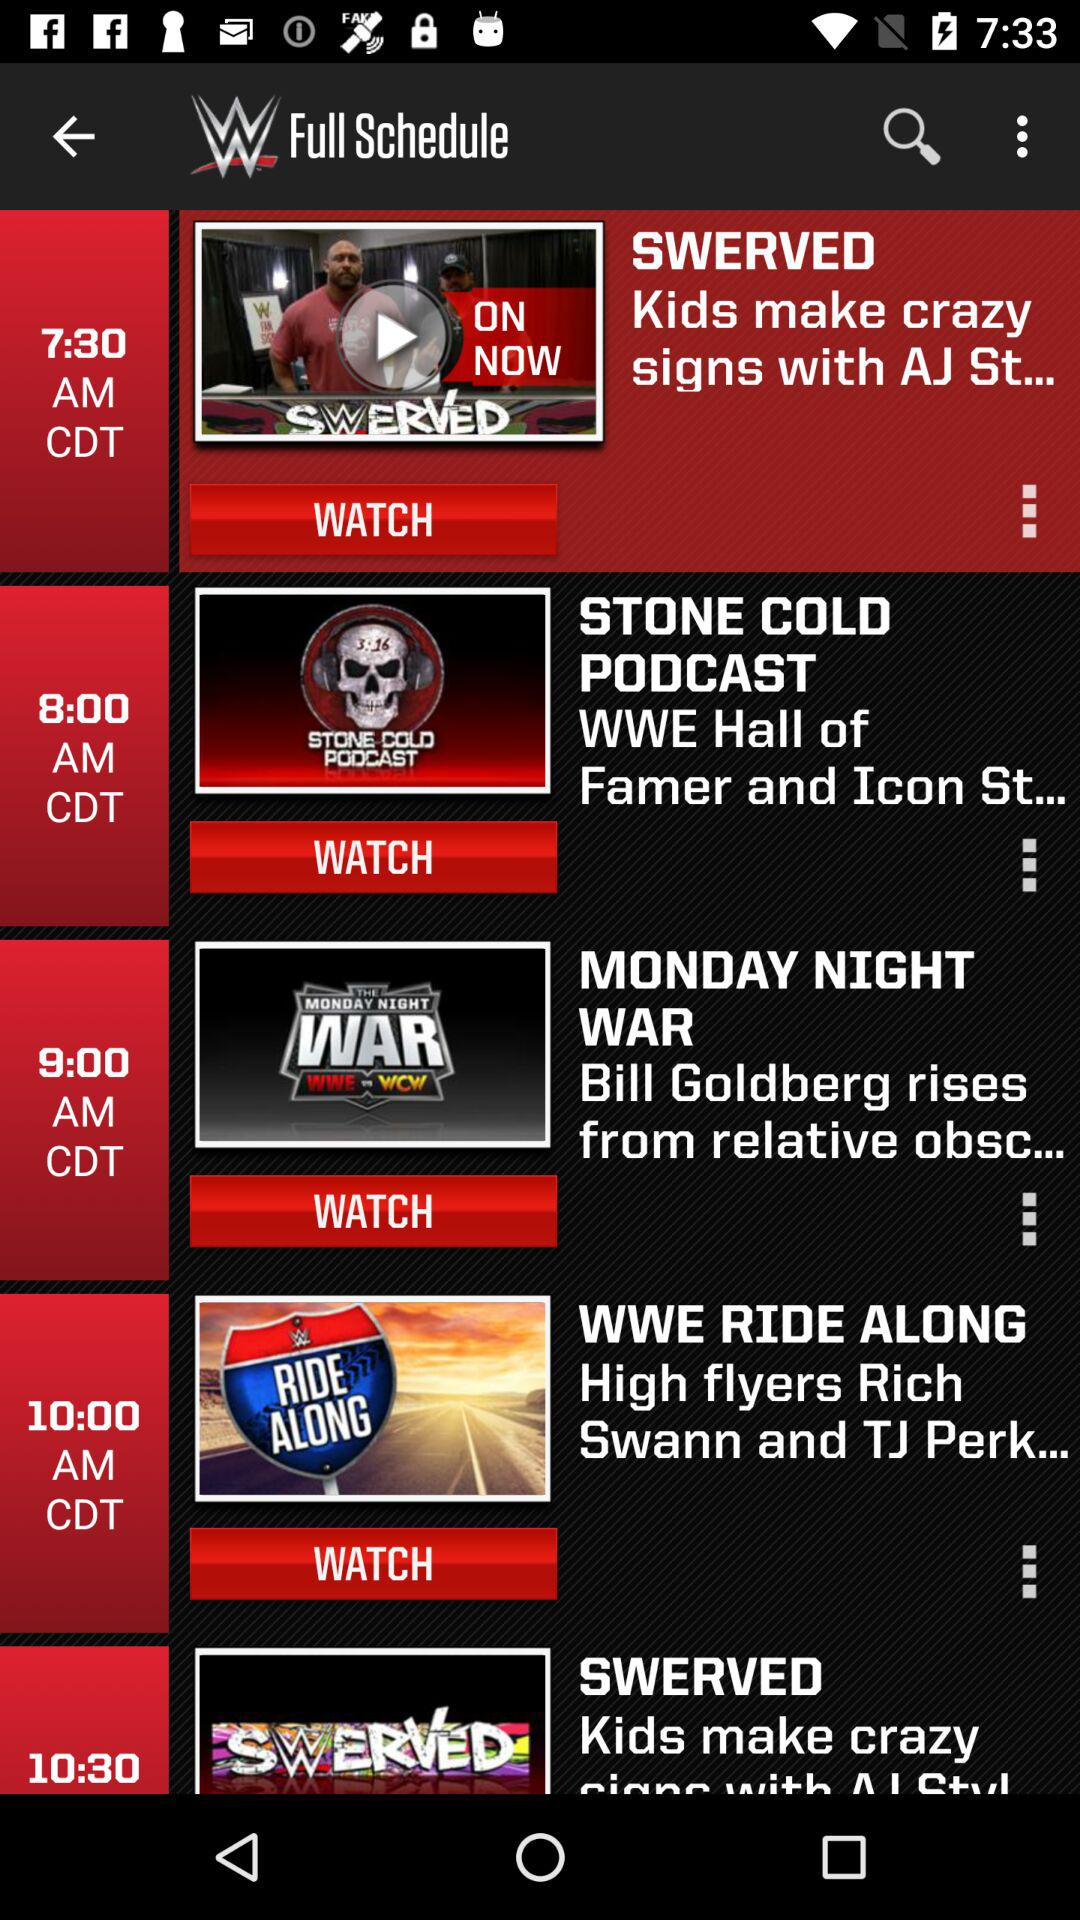What is the time of "MONDAY NIGHT WAR"? The time of "MONDAY NIGHT WAR" is 9 a.m. in Central Daylight Time. 